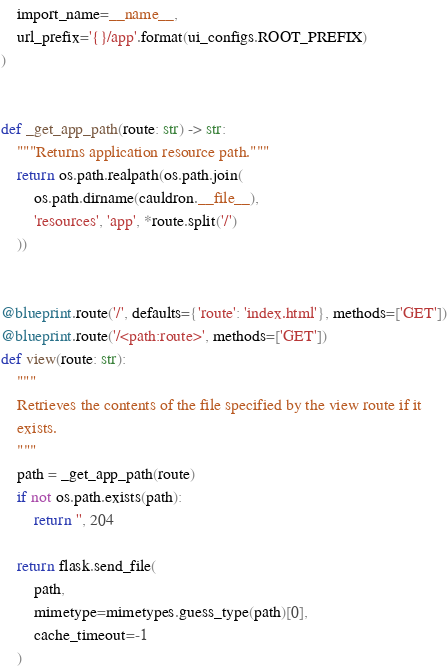Convert code to text. <code><loc_0><loc_0><loc_500><loc_500><_Python_>    import_name=__name__,
    url_prefix='{}/app'.format(ui_configs.ROOT_PREFIX)
)


def _get_app_path(route: str) -> str:
    """Returns application resource path."""
    return os.path.realpath(os.path.join(
        os.path.dirname(cauldron.__file__),
        'resources', 'app', *route.split('/')
    ))


@blueprint.route('/', defaults={'route': 'index.html'}, methods=['GET'])
@blueprint.route('/<path:route>', methods=['GET'])
def view(route: str):
    """
    Retrieves the contents of the file specified by the view route if it
    exists.
    """
    path = _get_app_path(route)
    if not os.path.exists(path):
        return '', 204

    return flask.send_file(
        path,
        mimetype=mimetypes.guess_type(path)[0],
        cache_timeout=-1
    )
</code> 